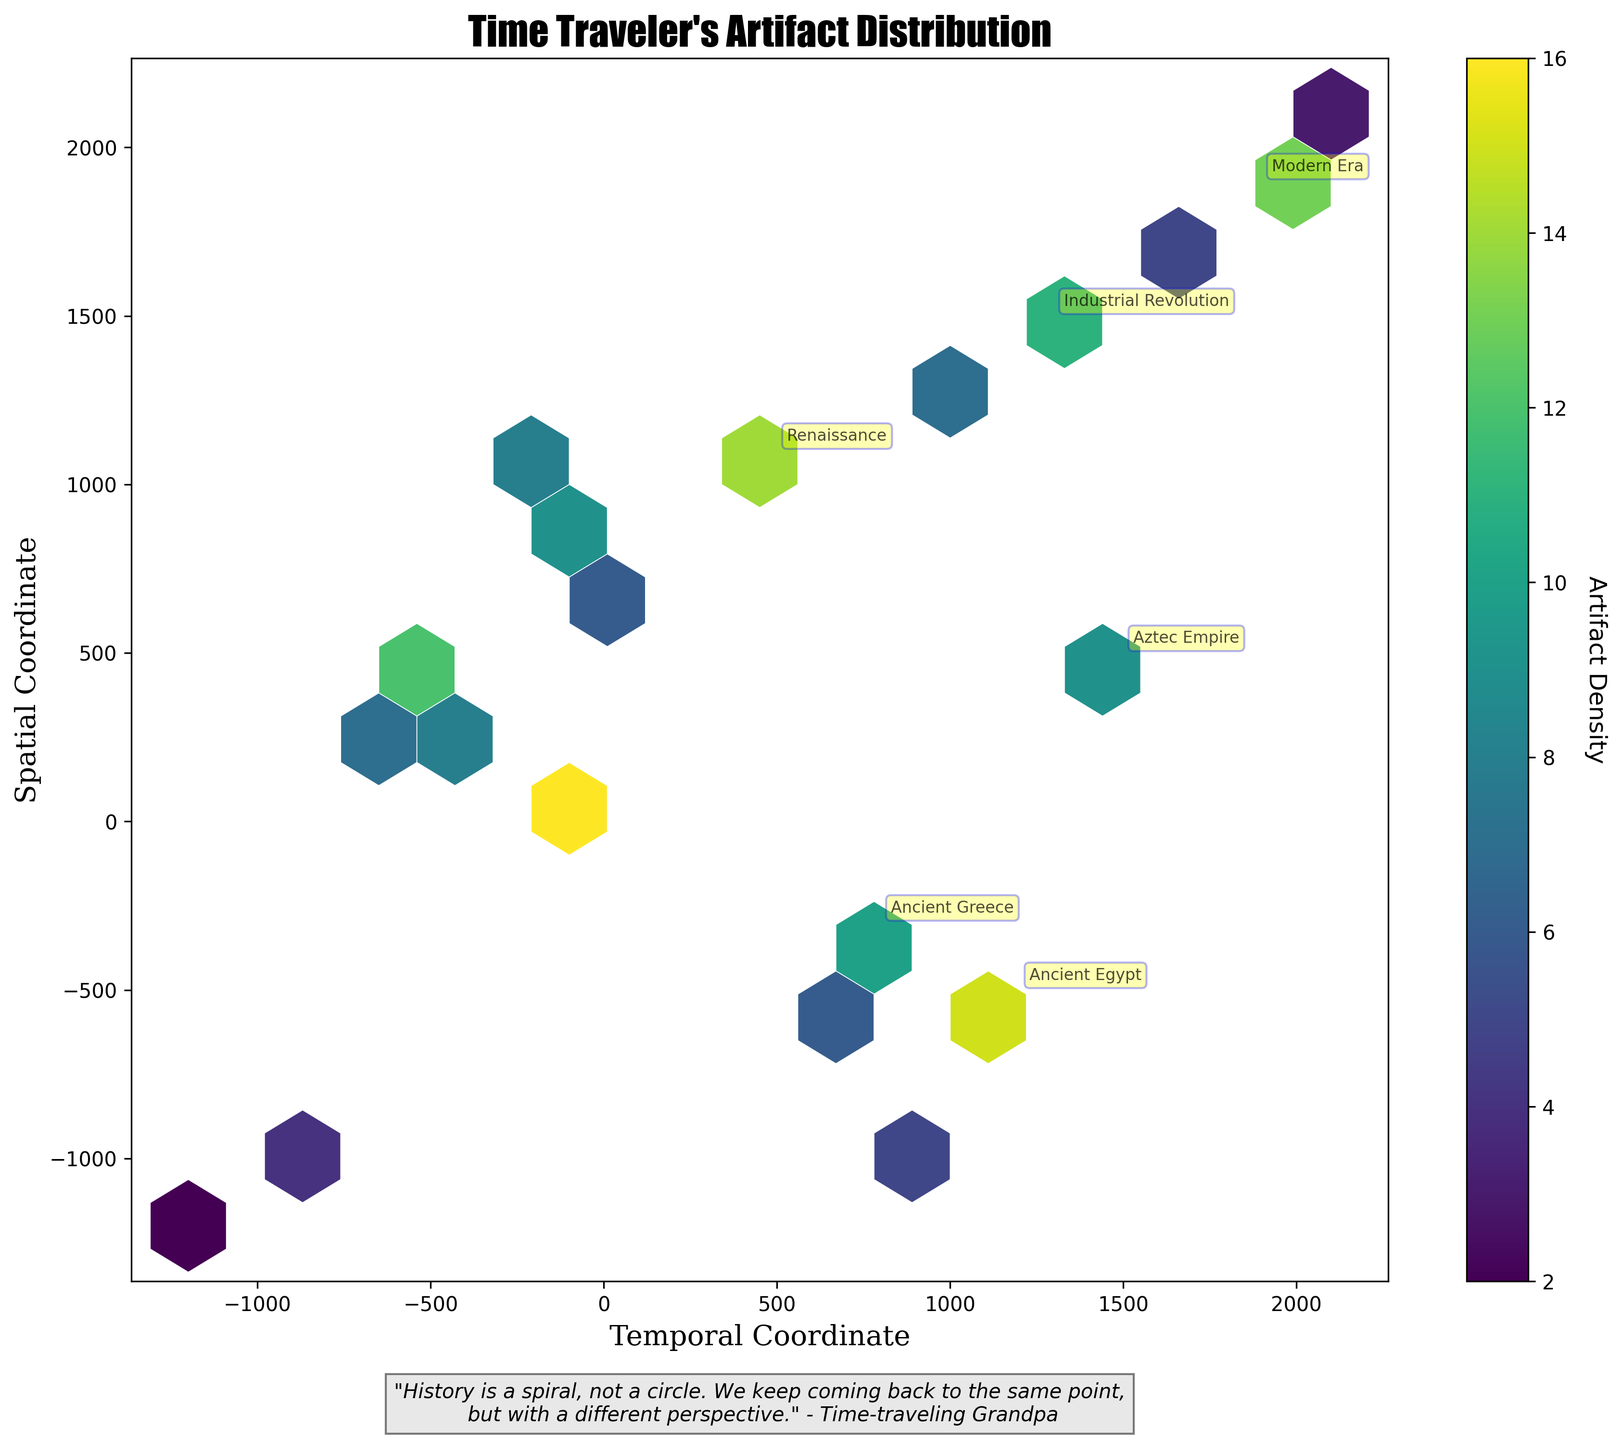What is the title of the plot? The title of the plot is displayed prominently at the top. It reads "Time Traveler's Artifact Distribution".
Answer: Time Traveler's Artifact Distribution What does the colorbar represent? The colorbar indicates the artifact density, showing how the colors in the hexbin plot correspond to different densities of artifacts.
Answer: Artifact Density Which eras have artifacts with 'High' significance annotated on the plot? Annotated points represent eras with 'High' significance, indicated by names near specific coordinates. The eras are Ancient Egypt, Ancient Greece, Renaissance, Industrial Revolution, Aztec Empire, and Modern Era.
Answer: Ancient Egypt, Ancient Greece, Renaissance, Industrial Revolution, Aztec Empire, Modern Era What are the x and y coordinates for the 'Modern Era' with high significance? The annotated 'Modern Era' on the plot is at coordinates (1900, 1900). This can be seen by locating the labeled point.
Answer: (1900, 1900) How many hexagons are colored in the highest density? Determine the hexagons with the darkest color, matching the top level of the colorbar. By counting these, we find the number.
Answer: 1 Which era has the highest density of artifacts located closest to the origin? By examining the hexbin plot around the origin (0, 0), the era labeled 'Various' appears to have the highest density, with an annotated point and dark color density near the center.
Answer: Various Which two eras are closest to each other in spatial coordinate based on high significance annotations? By comparing annotated eras, 'Aztec Empire' at (1500, 500) and 'Industrial Revolution' at (1300, 1500) are closest to each other on the spatial coordinate.
Answer: Aztec Empire and Industrial Revolution Compare artifact density between 'Ancient Greece' and 'Viking Age'. Which era has higher density? Using the color density and labels, 'Ancient Greece' has a denser color than 'Viking Age', indicating higher density.
Answer: Ancient Greece What patterns can be observed in the artifact distribution with respect to temporal and spatial coordinates? Observe the plot's distribution of hexagons. Artifacts with high density clusters are close to certain regions, like near the origin, and specific coordinates associated with significant historical eras.
Answer: High density clusters near the origin and notable coordinates What is the significant message conveyed at the bottom of the plot? The message at the bottom conveys a philosophical note about history, reading: "History is a spiral, not a circle. We keep coming back to the same point, but with a different perspective." - Time-traveling Grandpa.
Answer: "History is a spiral, not a circle. We keep coming back to the same point, but with a different perspective." - Time-traveling Grandpa 